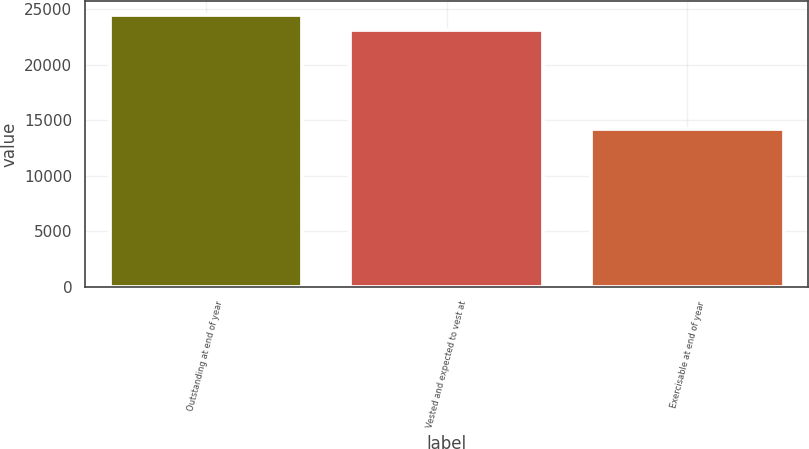<chart> <loc_0><loc_0><loc_500><loc_500><bar_chart><fcel>Outstanding at end of year<fcel>Vested and expected to vest at<fcel>Exercisable at end of year<nl><fcel>24472<fcel>23152<fcel>14174<nl></chart> 